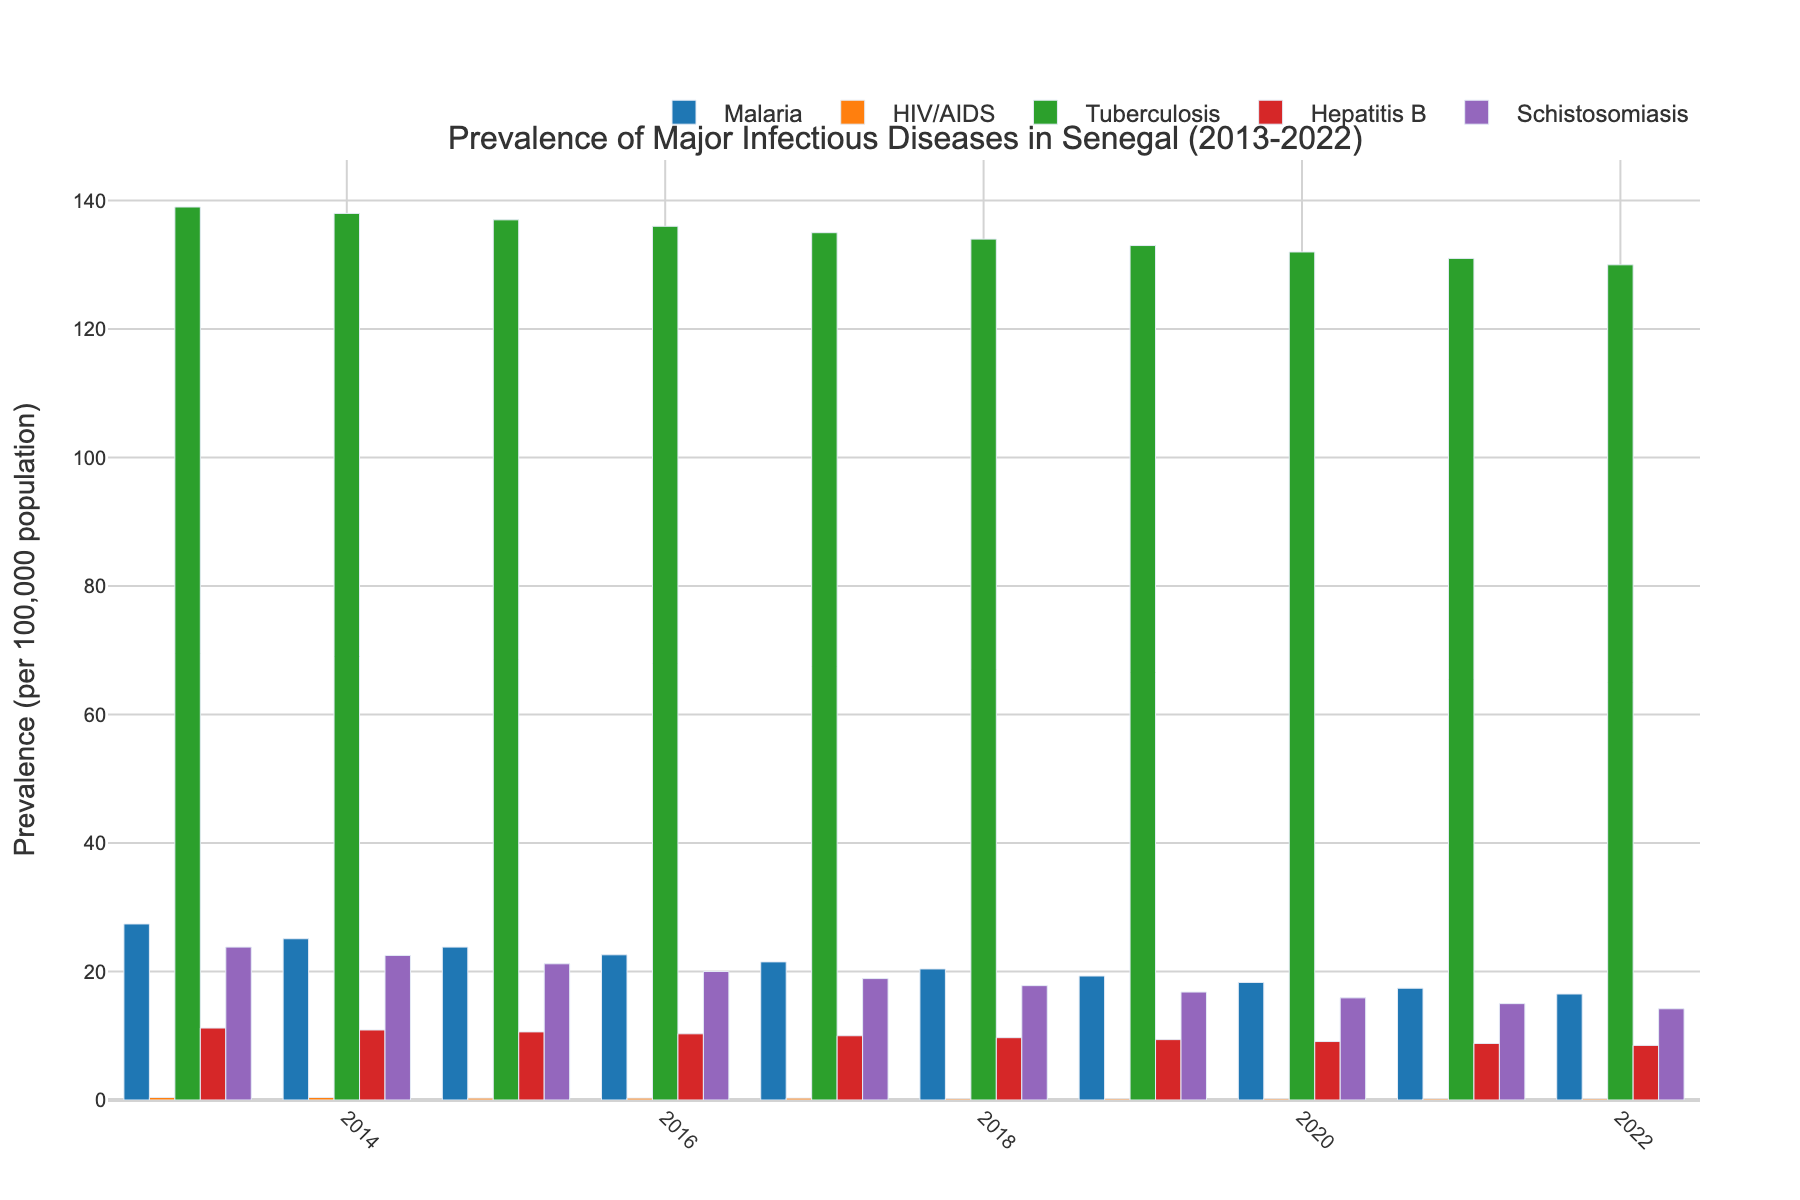What is the trend observed in malaria prevalence over the decade? The malaria prevalence shows a consistent declining trend from 27.4 in 2013 to 16.5 in 2022, indicating a reduction over the decade.
Answer: Consistent decline Which disease had the highest prevalence in 2013, and what was its value? In 2013, Tuberculosis had the highest prevalence with a value of 139 per 100,000 population.
Answer: Tuberculosis, 139 How did the prevalence of HIV/AIDS change from 2013 to 2022? The prevalence of HIV/AIDS remained relatively stable, decreasing slightly from 0.4 in 2013 to 0.2 in 2022.
Answer: Stable, slight decrease Compare the prevalence of Hepatitis B in 2015 and 2022. Which year had a higher value, and by how much? In 2015, the prevalence of Hepatitis B was 10.6, whereas in 2022 it was 8.5. The year 2015 had a higher value by 2.1.
Answer: 2015, 2.1 Which disease shows the most significant decrease in prevalence from 2013 to 2022? Malaria shows the most significant decrease in prevalence, reducing from 27.4 in 2013 to 16.5 in 2022, a drop of 10.9.
Answer: Malaria, 10.9 What are the values for Schistosomiasis prevalence in 2019 and 2020, and how do they compare? The prevalence of Schistosomiasis in 2019 was 16.8, and in 2020 it was 15.9. The prevalence decreased by 0.9 from 2019 to 2020.
Answer: 2019: 16.8, 2020: 15.9, decrease by 0.9 Calculate the average prevalence of Tuberculosis over the entire decade. Sum of tuberculosis prevalence values from 2013 to 2022 is (139 + 138 + 137 + 136 + 135 + 134 + 133 + 132 + 131 + 130) = 1345. Dividing this by 10 years gives an average of 134.5.
Answer: 134.5 Which disease had the least variation in prevalence between 2013 and 2022? HIV/AIDS had the least variation in prevalence, fluctuating slightly between 0.4 and 0.2 over the decade.
Answer: HIV/AIDS Identify the year with the lowest prevalence of Schistosomiasis and specify its value. The year with the lowest prevalence of Schistosomiasis is 2022, with a value of 14.2.
Answer: 2022, 14.2 What is the cumulative decrease in prevalence for Hepatitis B from 2013 to 2022? The prevalence of Hepatitis B decreased from 11.2 in 2013 to 8.5 in 2022. The cumulative decrease is 11.2 - 8.5 = 2.7.
Answer: 2.7 